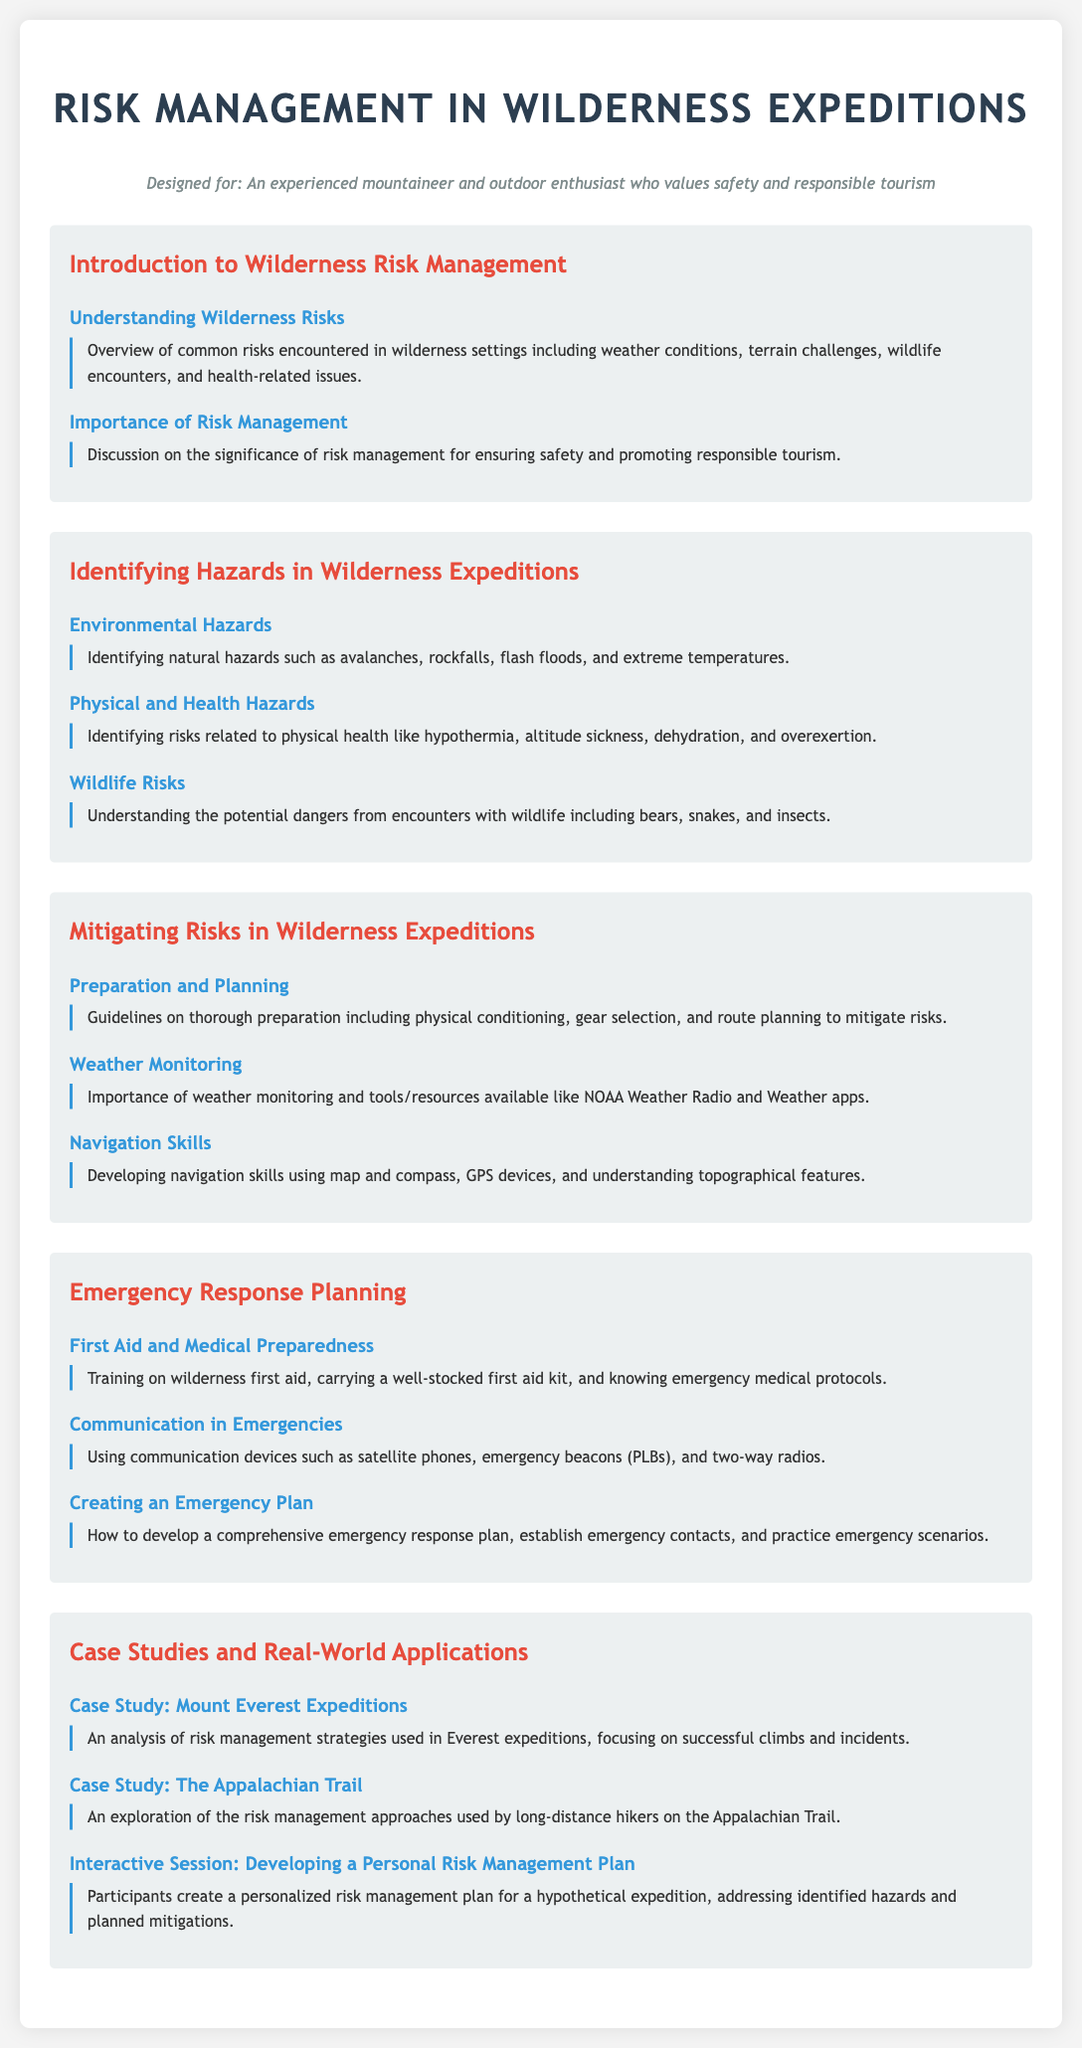What topics are covered in the Introduction to Wilderness Risk Management module? The Introduction to Wilderness Risk Management module covers the topics "Understanding Wilderness Risks" and "Importance of Risk Management."
Answer: Understanding Wilderness Risks, Importance of Risk Management What are examples of Environmental Hazards discussed? Environmental Hazards in the syllabus include natural hazards such as avalanches, rockfalls, flash floods, and extreme temperatures.
Answer: Avalanches, rockfalls, flash floods, extreme temperatures What skills are emphasized for navigation in the Mitigating Risks module? The Mitigating Risks module emphasizes developing navigation skills using map and compass, GPS devices, and understanding topographical features.
Answer: Map and compass, GPS devices, topographical features What is highlighted as important for emergency communication? The syllabus highlights the importance of using communication devices such as satellite phones, emergency beacons, and two-way radios for emergencies.
Answer: Satellite phones, emergency beacons, two-way radios How many case studies are provided in the syllabus? The syllabus includes three case studies within the Case Studies and Real-World Applications module.
Answer: Three 